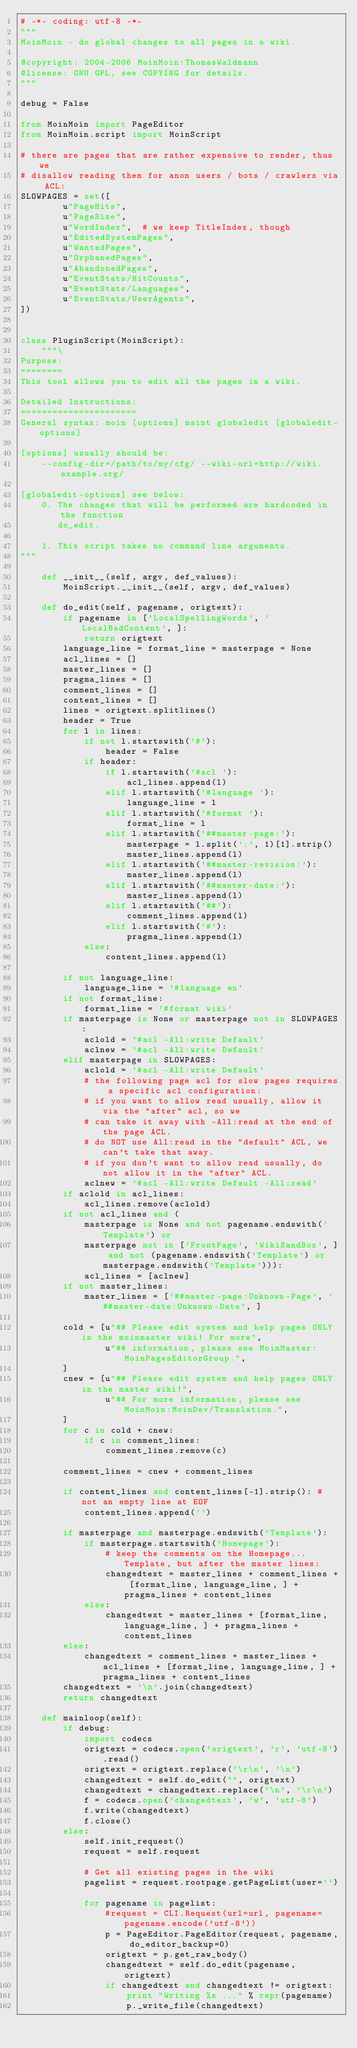Convert code to text. <code><loc_0><loc_0><loc_500><loc_500><_Python_># -*- coding: utf-8 -*-
"""
MoinMoin - do global changes to all pages in a wiki.

@copyright: 2004-2006 MoinMoin:ThomasWaldmann
@license: GNU GPL, see COPYING for details.
"""

debug = False

from MoinMoin import PageEditor
from MoinMoin.script import MoinScript

# there are pages that are rather expensive to render, thus we
# disallow reading them for anon users / bots / crawlers via ACL:
SLOWPAGES = set([
        u"PageHits",
        u"PageSize",
        u"WordIndex",  # we keep TitleIndex, though
        u"EditedSystemPages",
        u"WantedPages",
        u"OrphanedPages",
        u"AbandonedPages",
        u"EventStats/HitCounts",
        u"EventStats/Languages",
        u"EventStats/UserAgents",
])


class PluginScript(MoinScript):
    """\
Purpose:
========
This tool allows you to edit all the pages in a wiki.

Detailed Instructions:
======================
General syntax: moin [options] maint globaledit [globaledit-options]

[options] usually should be:
    --config-dir=/path/to/my/cfg/ --wiki-url=http://wiki.example.org/

[globaledit-options] see below:
    0. The changes that will be performed are hardcoded in the function
       do_edit.

    1. This script takes no command line arguments.
"""

    def __init__(self, argv, def_values):
        MoinScript.__init__(self, argv, def_values)

    def do_edit(self, pagename, origtext):
        if pagename in ['LocalSpellingWords', 'LocalBadContent', ]:
            return origtext
        language_line = format_line = masterpage = None
        acl_lines = []
        master_lines = []
        pragma_lines = []
        comment_lines = []
        content_lines = []
        lines = origtext.splitlines()
        header = True
        for l in lines:
            if not l.startswith('#'):
                header = False
            if header:
                if l.startswith('#acl '):
                    acl_lines.append(l)
                elif l.startswith('#language '):
                    language_line = l
                elif l.startswith('#format '):
                    format_line = l
                elif l.startswith('##master-page:'):
                    masterpage = l.split(':', 1)[1].strip()
                    master_lines.append(l)
                elif l.startswith('##master-revision:'):
                    master_lines.append(l)
                elif l.startswith('##master-date:'):
                    master_lines.append(l)
                elif l.startswith('##'):
                    comment_lines.append(l)
                elif l.startswith('#'):
                    pragma_lines.append(l)
            else:
                content_lines.append(l)

        if not language_line:
            language_line = '#language en'
        if not format_line:
            format_line = '#format wiki'
        if masterpage is None or masterpage not in SLOWPAGES:
            aclold = '#acl -All:write Default'
            aclnew = '#acl -All:write Default'
        elif masterpage in SLOWPAGES:
            aclold = '#acl -All:write Default'
            # the following page acl for slow pages requires a specific acl configuration:
            # if you want to allow read usually, allow it via the "after" acl, so we
            # can take it away with -All:read at the end of the page ACL.
            # do NOT use All:read in the "default" ACL, we can't take that away.
            # if you don't want to allow read usually, do not allow it in the "after" ACL.
            aclnew = '#acl -All:write Default -All:read'
        if aclold in acl_lines:
            acl_lines.remove(aclold)
        if not acl_lines and (
            masterpage is None and not pagename.endswith('Template') or
            masterpage not in ['FrontPage', 'WikiSandBox', ] and not (pagename.endswith('Template') or masterpage.endswith('Template'))):
            acl_lines = [aclnew]
        if not master_lines:
            master_lines = ['##master-page:Unknown-Page', '##master-date:Unknown-Date', ]

        cold = [u"## Please edit system and help pages ONLY in the moinmaster wiki! For more",
                u"## information, please see MoinMaster:MoinPagesEditorGroup.",
        ]
        cnew = [u"## Please edit system and help pages ONLY in the master wiki!",
                u"## For more information, please see MoinMoin:MoinDev/Translation.",
        ]
        for c in cold + cnew:
            if c in comment_lines:
                comment_lines.remove(c)

        comment_lines = cnew + comment_lines

        if content_lines and content_lines[-1].strip(): # not an empty line at EOF
            content_lines.append('')

        if masterpage and masterpage.endswith('Template'):
            if masterpage.startswith('Homepage'):
                # keep the comments on the Homepage...Template, but after the master lines:
                changedtext = master_lines + comment_lines + [format_line, language_line, ] + pragma_lines + content_lines
            else:
                changedtext = master_lines + [format_line, language_line, ] + pragma_lines + content_lines
        else:
            changedtext = comment_lines + master_lines + acl_lines + [format_line, language_line, ] + pragma_lines + content_lines
        changedtext = '\n'.join(changedtext)
        return changedtext

    def mainloop(self):
        if debug:
            import codecs
            origtext = codecs.open('origtext', 'r', 'utf-8').read()
            origtext = origtext.replace('\r\n', '\n')
            changedtext = self.do_edit("", origtext)
            changedtext = changedtext.replace('\n', '\r\n')
            f = codecs.open('changedtext', 'w', 'utf-8')
            f.write(changedtext)
            f.close()
        else:
            self.init_request()
            request = self.request

            # Get all existing pages in the wiki
            pagelist = request.rootpage.getPageList(user='')

            for pagename in pagelist:
                #request = CLI.Request(url=url, pagename=pagename.encode('utf-8'))
                p = PageEditor.PageEditor(request, pagename, do_editor_backup=0)
                origtext = p.get_raw_body()
                changedtext = self.do_edit(pagename, origtext)
                if changedtext and changedtext != origtext:
                    print "Writing %s ..." % repr(pagename)
                    p._write_file(changedtext)

</code> 